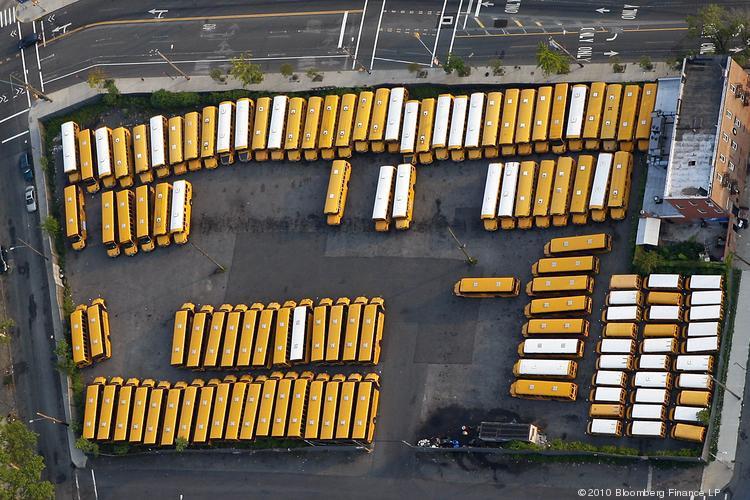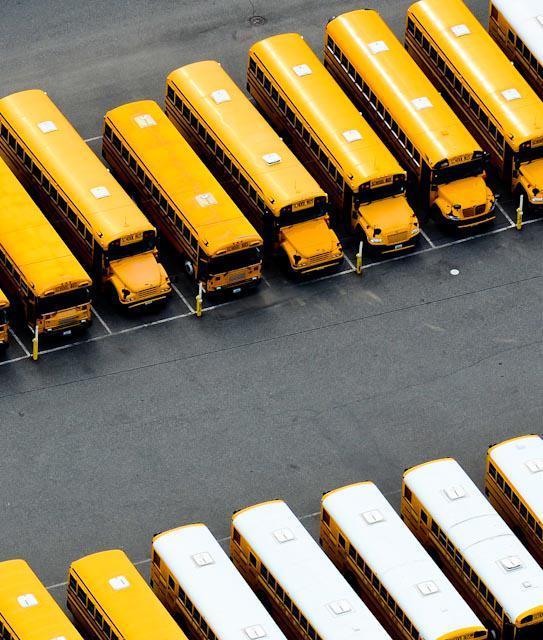The first image is the image on the left, the second image is the image on the right. Analyze the images presented: Is the assertion "Words are written across the side of a school bus in the image on the right." valid? Answer yes or no. No. The first image is the image on the left, the second image is the image on the right. Considering the images on both sides, is "The right image contains an aerial view of a school bus parking lot." valid? Answer yes or no. Yes. 